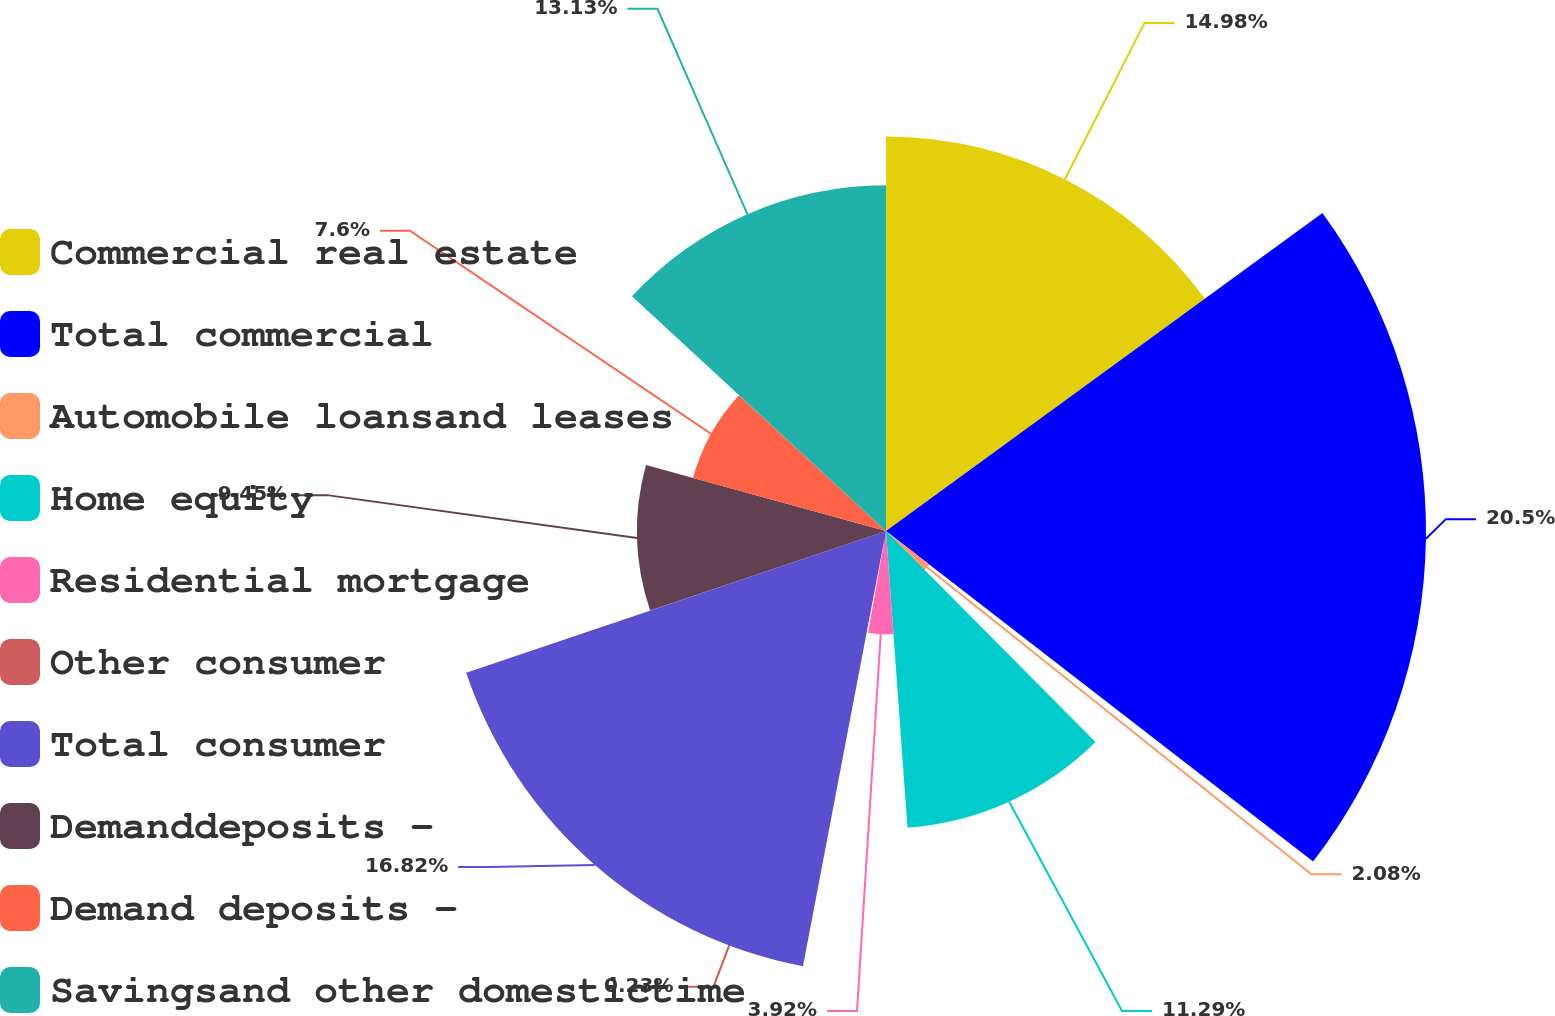<chart> <loc_0><loc_0><loc_500><loc_500><pie_chart><fcel>Commercial real estate<fcel>Total commercial<fcel>Automobile loansand leases<fcel>Home equity<fcel>Residential mortgage<fcel>Other consumer<fcel>Total consumer<fcel>Demanddeposits -<fcel>Demand deposits -<fcel>Savingsand other domestictime<nl><fcel>14.98%<fcel>20.5%<fcel>2.08%<fcel>11.29%<fcel>3.92%<fcel>0.23%<fcel>16.82%<fcel>9.45%<fcel>7.6%<fcel>13.13%<nl></chart> 